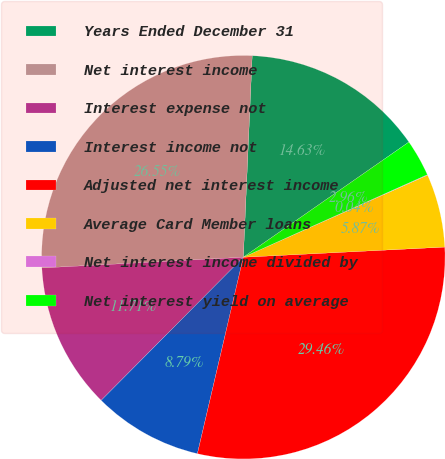<chart> <loc_0><loc_0><loc_500><loc_500><pie_chart><fcel>Years Ended December 31<fcel>Net interest income<fcel>Interest expense not<fcel>Interest income not<fcel>Adjusted net interest income<fcel>Average Card Member loans<fcel>Net interest income divided by<fcel>Net interest yield on average<nl><fcel>14.63%<fcel>26.55%<fcel>11.71%<fcel>8.79%<fcel>29.46%<fcel>5.87%<fcel>0.04%<fcel>2.96%<nl></chart> 